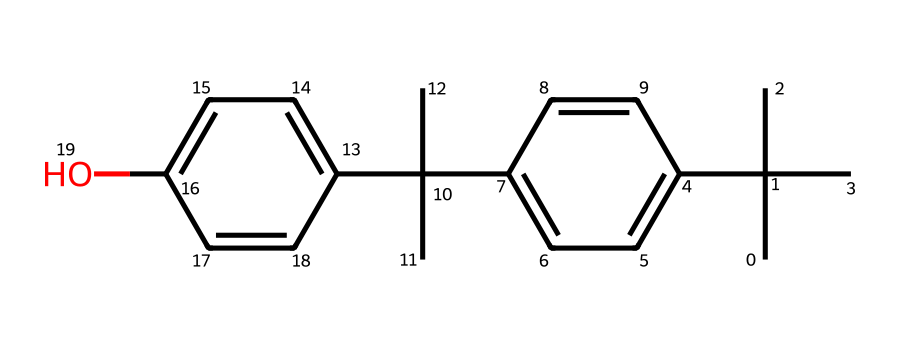What is the molecular formula of this compound? By examining the structure represented in the SMILES notation, we can determine the number of carbon (C), hydrogen (H), and oxygen (O) atoms present. This compound contains 20 carbon atoms, 30 hydrogen atoms, and 1 oxygen atom, leading to the molecular formula C20H30O.
Answer: C20H30O How many hydroxyl (-OH) groups are present in this molecule? In the SMILES representation, the molecule contains a phenolic group with a single hydroxyl (-OH) group. Therefore, after reviewing the structure, it is evident there is one hydroxyl group.
Answer: 1 What is the primary use of this compound in skin care? This compound is primarily used as a UV filter or sunscreen agent in skin care products due to its ability to absorb UV radiation and protect skin from damage.
Answer: UV filter Is this compound a saturated or unsaturated chemical? By analyzing the structure, we can note that the presence of only single bonds between carbon atoms indicates that it is saturated, as there are no double bonds.
Answer: saturated What type of chemical is this compound classified as? This chemical is classified as a phenolic compound due to the presence of a hydroxyl group (-OH) attached to a aromatic ring structure, typical for phenols that provide protective properties against UV radiation.
Answer: phenolic compound What is the total number of aromatic rings in the structure? Upon inspecting the SMILES notation, the compound exhibits two phenyl groups, indicating it possesses two aromatic rings in its structure.
Answer: 2 